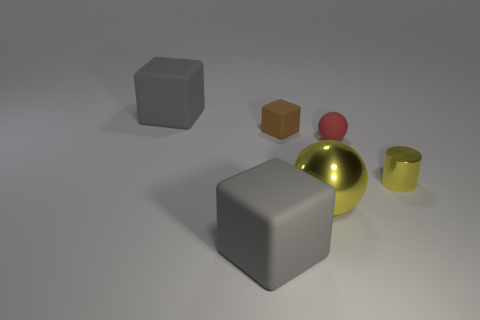Subtract all big gray cubes. How many cubes are left? 1 Subtract all purple cylinders. How many gray cubes are left? 2 Add 2 gray things. How many objects exist? 8 Subtract all cylinders. How many objects are left? 5 Subtract all yellow cubes. Subtract all cyan spheres. How many cubes are left? 3 Add 1 gray rubber things. How many gray rubber things are left? 3 Add 6 big green things. How many big green things exist? 6 Subtract 0 green balls. How many objects are left? 6 Subtract all small metallic cylinders. Subtract all big blue metal objects. How many objects are left? 5 